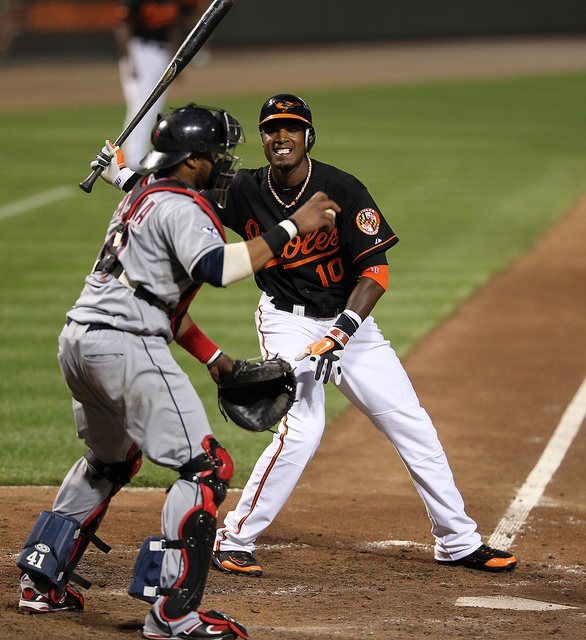Describe the objects in this image and their specific colors. I can see people in black, darkgray, gray, and lightgray tones, people in black, lavender, gray, and darkgray tones, baseball glove in black, gray, darkgreen, and olive tones, baseball bat in black, gray, lightgray, and darkgray tones, and sports ball in black, tan, and gray tones in this image. 